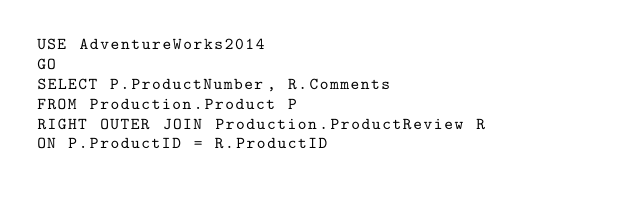<code> <loc_0><loc_0><loc_500><loc_500><_SQL_>USE AdventureWorks2014
GO
SELECT P.ProductNumber, R.Comments
FROM Production.Product P
RIGHT OUTER JOIN Production.ProductReview R
ON P.ProductID = R.ProductID</code> 